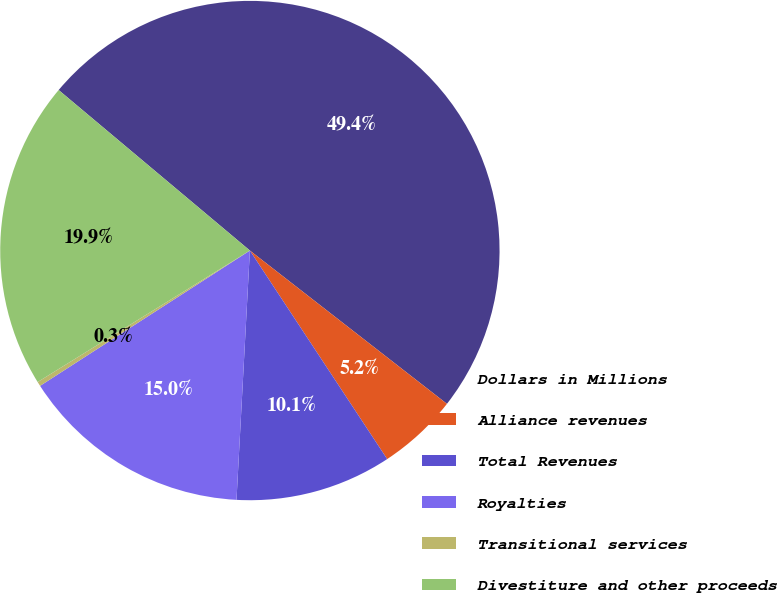Convert chart. <chart><loc_0><loc_0><loc_500><loc_500><pie_chart><fcel>Dollars in Millions<fcel>Alliance revenues<fcel>Total Revenues<fcel>Royalties<fcel>Transitional services<fcel>Divestiture and other proceeds<nl><fcel>49.41%<fcel>5.21%<fcel>10.12%<fcel>15.03%<fcel>0.29%<fcel>19.94%<nl></chart> 